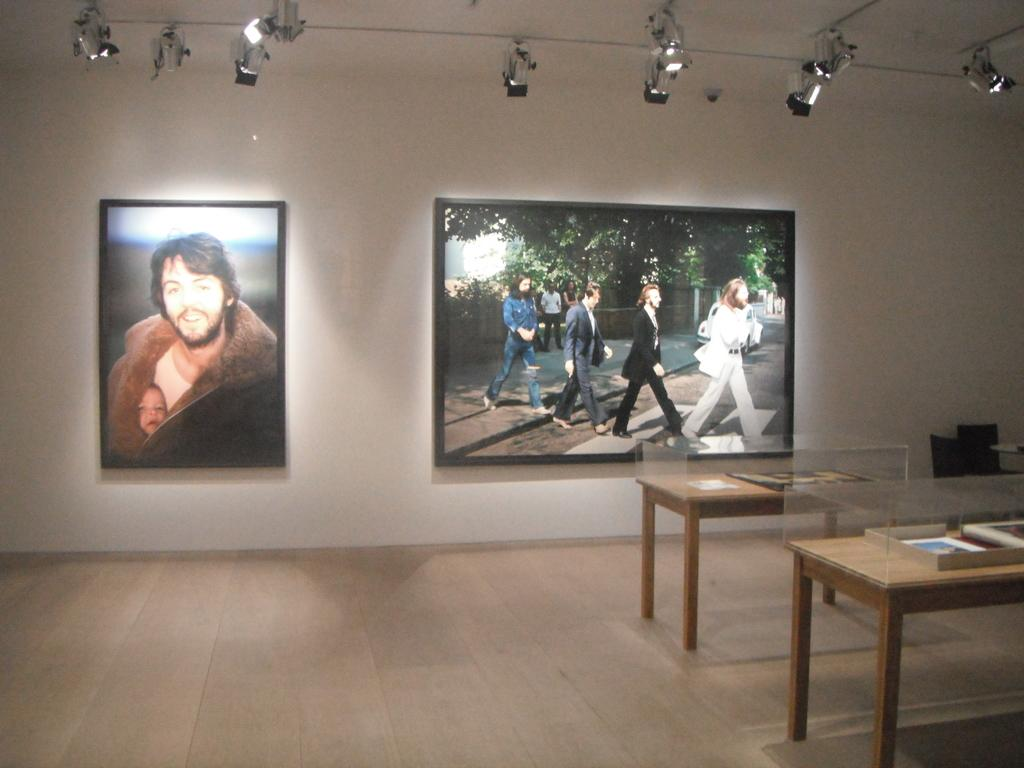What is located in the center of the image? There is a wall in the center of the image. What is hanging on the wall? There are two photo frames on the wall. How many tables are visible on the floor? There are two tables on the floor. What can be seen on the ceiling? There are lights on the ceiling. What type of coat is hanging on the wall in the image? There is no coat present in the image; it features a wall with two photo frames and lights on the ceiling. 